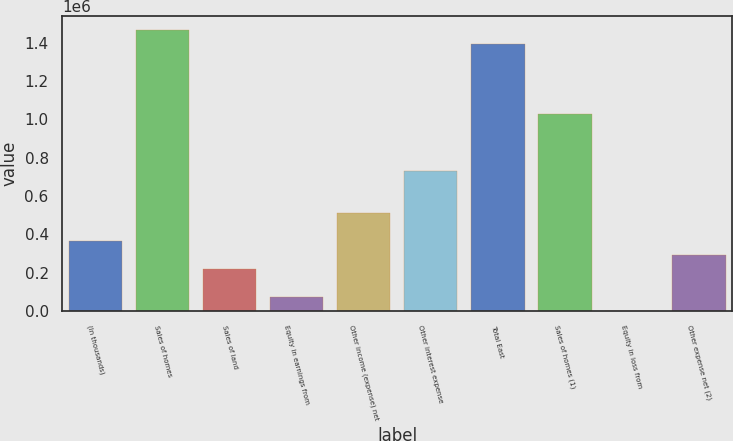Convert chart to OTSL. <chart><loc_0><loc_0><loc_500><loc_500><bar_chart><fcel>(In thousands)<fcel>Sales of homes<fcel>Sales of land<fcel>Equity in earnings from<fcel>Other income (expense) net<fcel>Other interest expense<fcel>Total East<fcel>Sales of homes (1)<fcel>Equity in loss from<fcel>Other expense net (2)<nl><fcel>366581<fcel>1.46606e+06<fcel>219983<fcel>73385.8<fcel>513179<fcel>733075<fcel>1.39276e+06<fcel>1.02627e+06<fcel>87<fcel>293282<nl></chart> 